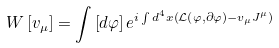Convert formula to latex. <formula><loc_0><loc_0><loc_500><loc_500>W \left [ v _ { \mu } \right ] = \int \left [ d \varphi \right ] e ^ { i \int d ^ { 4 } x \left ( \mathcal { L } \left ( \varphi , \partial \varphi \right ) - v _ { \mu } J ^ { \mu } \right ) }</formula> 